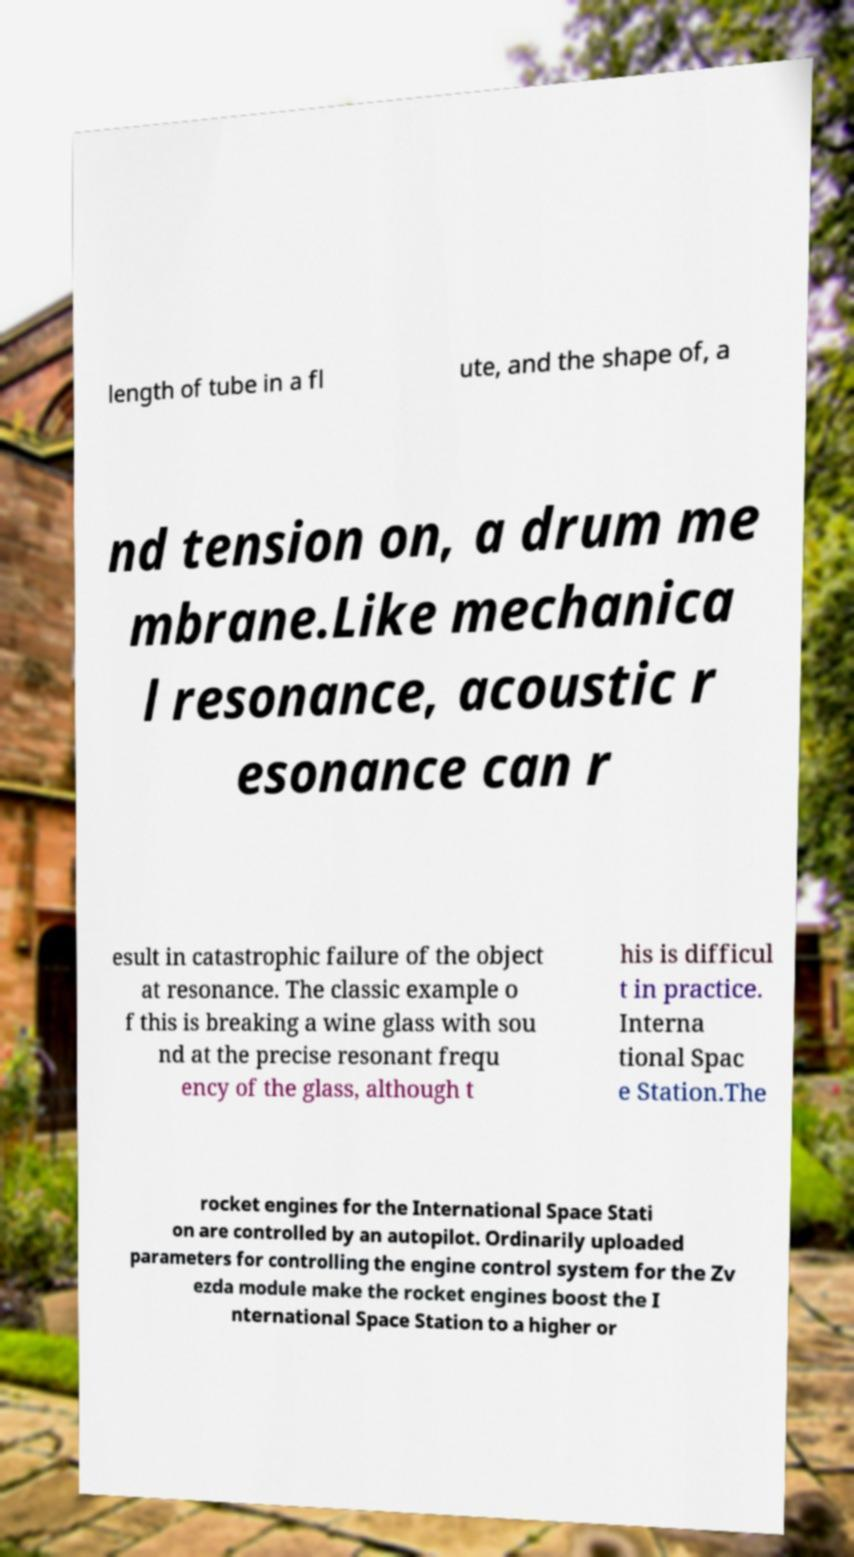I need the written content from this picture converted into text. Can you do that? length of tube in a fl ute, and the shape of, a nd tension on, a drum me mbrane.Like mechanica l resonance, acoustic r esonance can r esult in catastrophic failure of the object at resonance. The classic example o f this is breaking a wine glass with sou nd at the precise resonant frequ ency of the glass, although t his is difficul t in practice. Interna tional Spac e Station.The rocket engines for the International Space Stati on are controlled by an autopilot. Ordinarily uploaded parameters for controlling the engine control system for the Zv ezda module make the rocket engines boost the I nternational Space Station to a higher or 